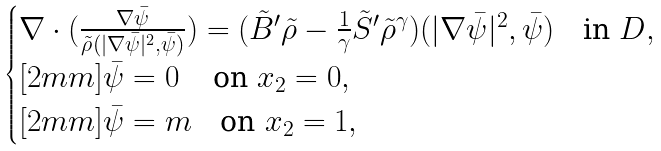Convert formula to latex. <formula><loc_0><loc_0><loc_500><loc_500>\begin{cases} \nabla \cdot ( \frac { \nabla \bar { \psi } } { \tilde { \rho } ( | \nabla \bar { \psi } | ^ { 2 } , \bar { \psi } ) } ) = ( \tilde { B } ^ { \prime } \tilde { \rho } - \frac { 1 } { \gamma } \tilde { S } ^ { \prime } \tilde { \rho } ^ { \gamma } ) ( | \nabla \bar { \psi } | ^ { 2 } , \bar { \psi } ) \quad \text {in} \ D , \\ [ 2 m m ] \bar { \psi } = 0 \quad \, \text {on} \ x _ { 2 } = 0 , \\ [ 2 m m ] \bar { \psi } = m \quad \text {on} \ x _ { 2 } = 1 , \end{cases}</formula> 